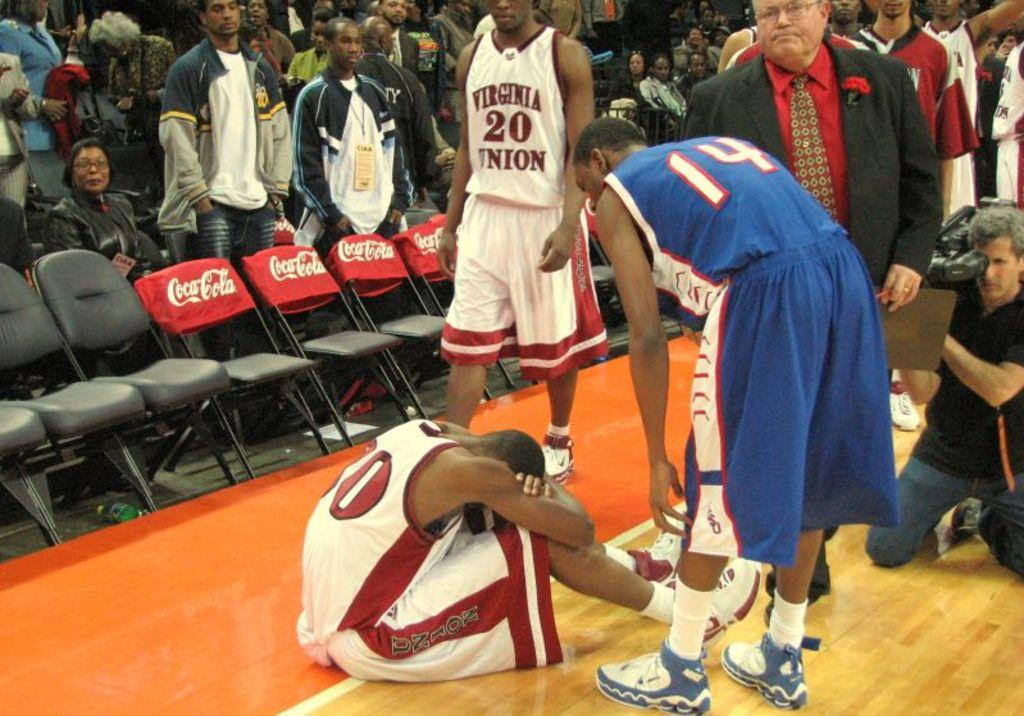<image>
Describe the image concisely. a player wearing blue and the number 14 helping a team member 